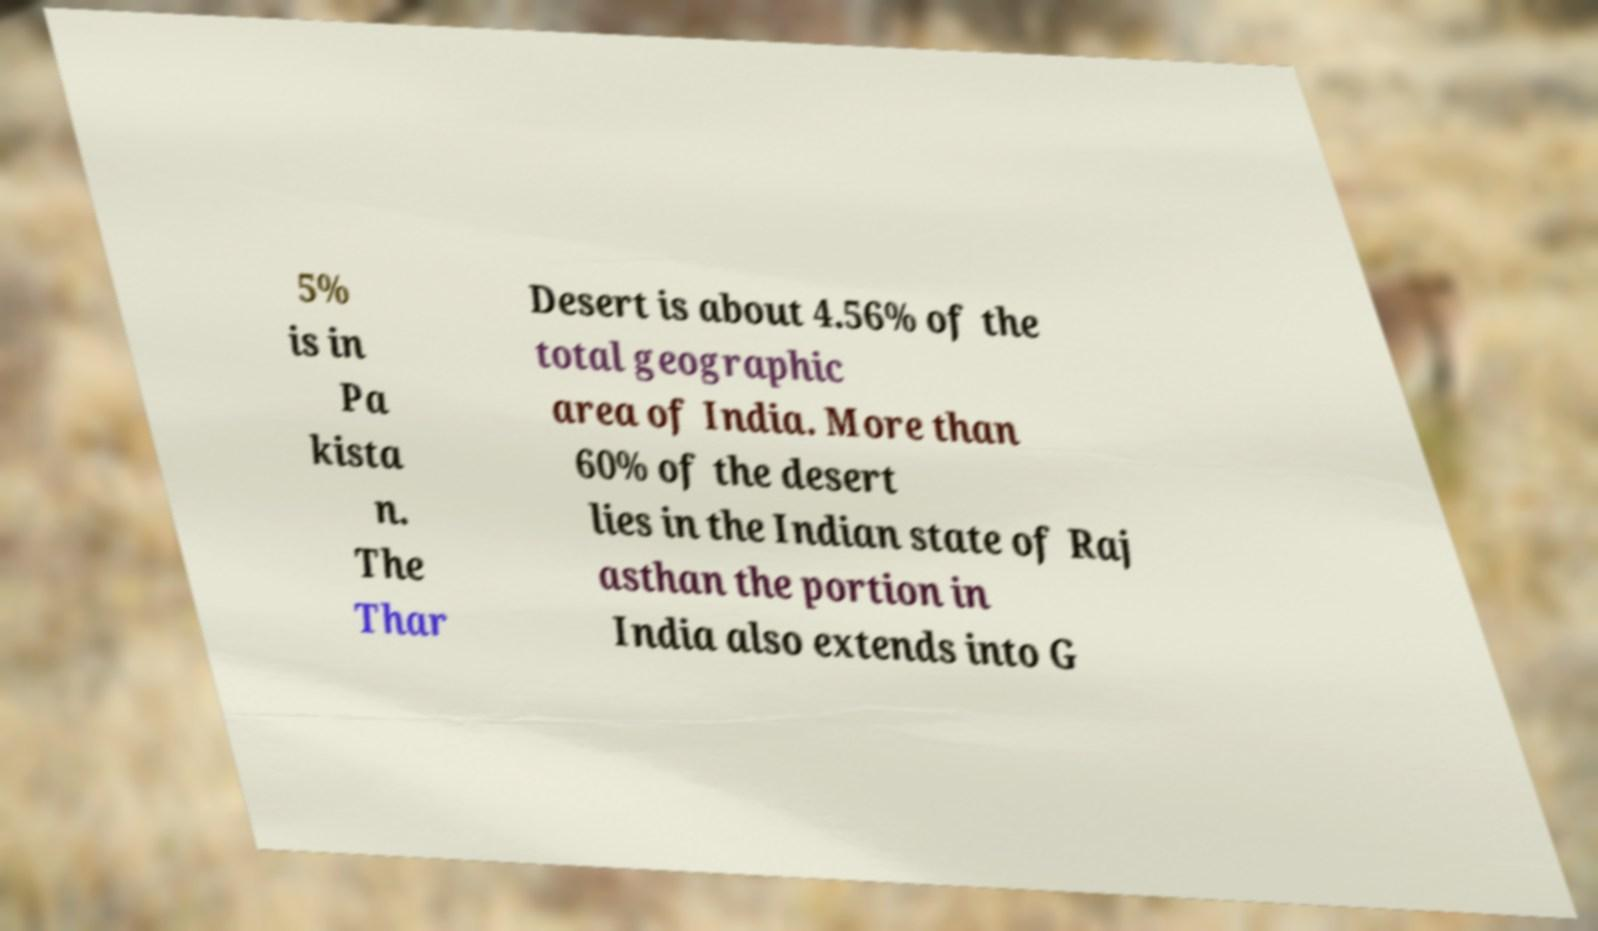For documentation purposes, I need the text within this image transcribed. Could you provide that? 5% is in Pa kista n. The Thar Desert is about 4.56% of the total geographic area of India. More than 60% of the desert lies in the Indian state of Raj asthan the portion in India also extends into G 